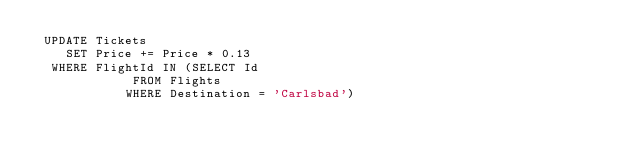<code> <loc_0><loc_0><loc_500><loc_500><_SQL_> UPDATE Tickets
    SET Price += Price * 0.13
  WHERE FlightId IN (SELECT Id 
					   FROM Flights
					  WHERE Destination = 'Carlsbad')</code> 